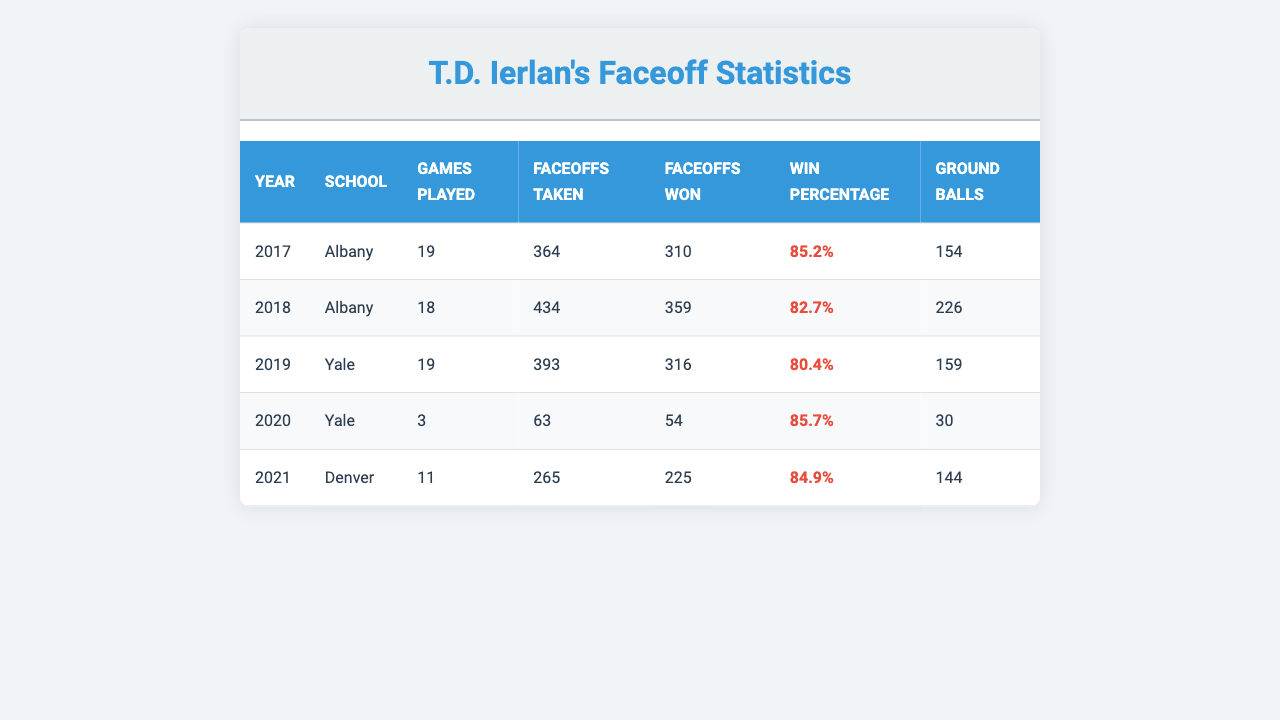What is T.D. Ierlan's highest win percentage in a single season? Referring to the table, the highest win percentage is found in the year 2017, where it is 85.2%.
Answer: 85.2% How many ground balls did T.D. Ierlan collect in total during his college career? Sum the ground balls from all years: 154 + 226 + 159 + 30 + 144 = 713.
Answer: 713 In which year did T.D. Ierlan play the most games? By checking the "Games Played" column, 2017 shows the highest number of games at 19.
Answer: 2017 What is the win percentage for T.D. Ierlan in 2020? The win percentage for the year 2020 from the table is 85.7%.
Answer: 85.7% Which school did T.D. Ierlan achieve the highest number of faceoffs won? Looking at the "Faceoffs Won" column, Albany in 2017 has the highest wins with 310.
Answer: Albany (2017) What was the average faceoff win percentage across all seasons? Calculate the average by summing the win percentage: (85.2 + 82.7 + 80.4 + 85.7 + 84.9) / 5 = 83.418.
Answer: 83.4 Did T.D. Ierlan maintain a win percentage above 80% for every year? Check each year's win percentage: 85.2%, 82.7%, 80.4%, 85.7%, and 84.9% — all are above 80%. Therefore, yes.
Answer: Yes Which season had the lowest number of faceoffs taken? The year 2020 shows the lowest "Faceoffs Taken" at 63.
Answer: 2020 Over his entire career, in what year did T.D. Ierlan have the fewest ground balls? Assess the "Ground Balls" column: 30 in 2020 is the lowest.
Answer: 2020 Calculate the difference in faceoffs won between the years 2019 and 2021. 2019 had 316 wins, and 2021 had 225 wins. So, 316 - 225 = 91.
Answer: 91 